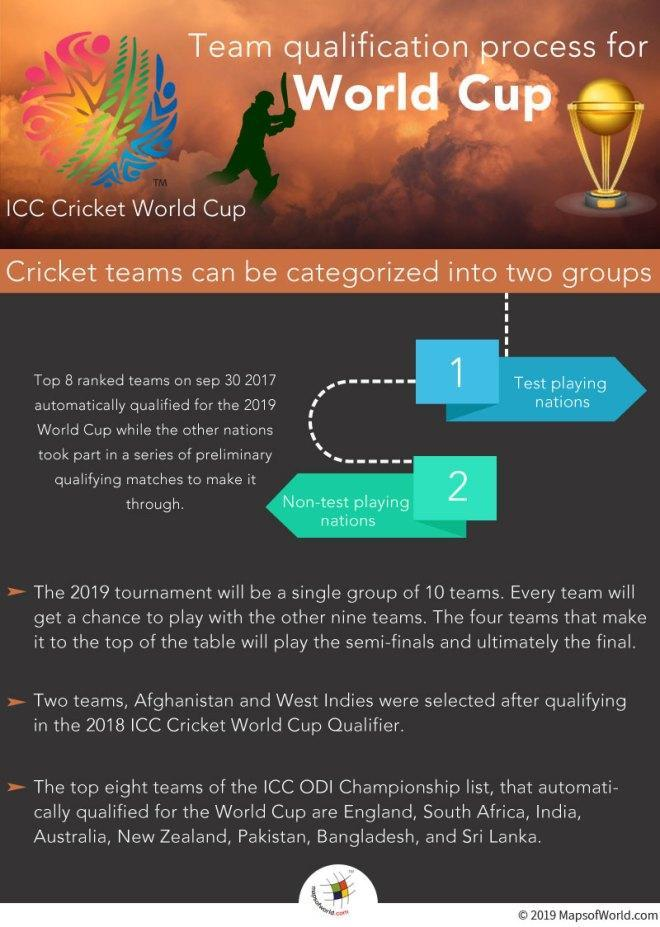What are the two categories of cricket?
Answer the question with a short phrase. Test playing nations, Non-test playing nations 